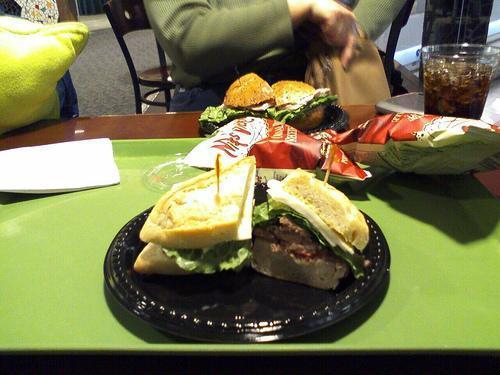How many sandwiches are in the photo?
Give a very brief answer. 4. 